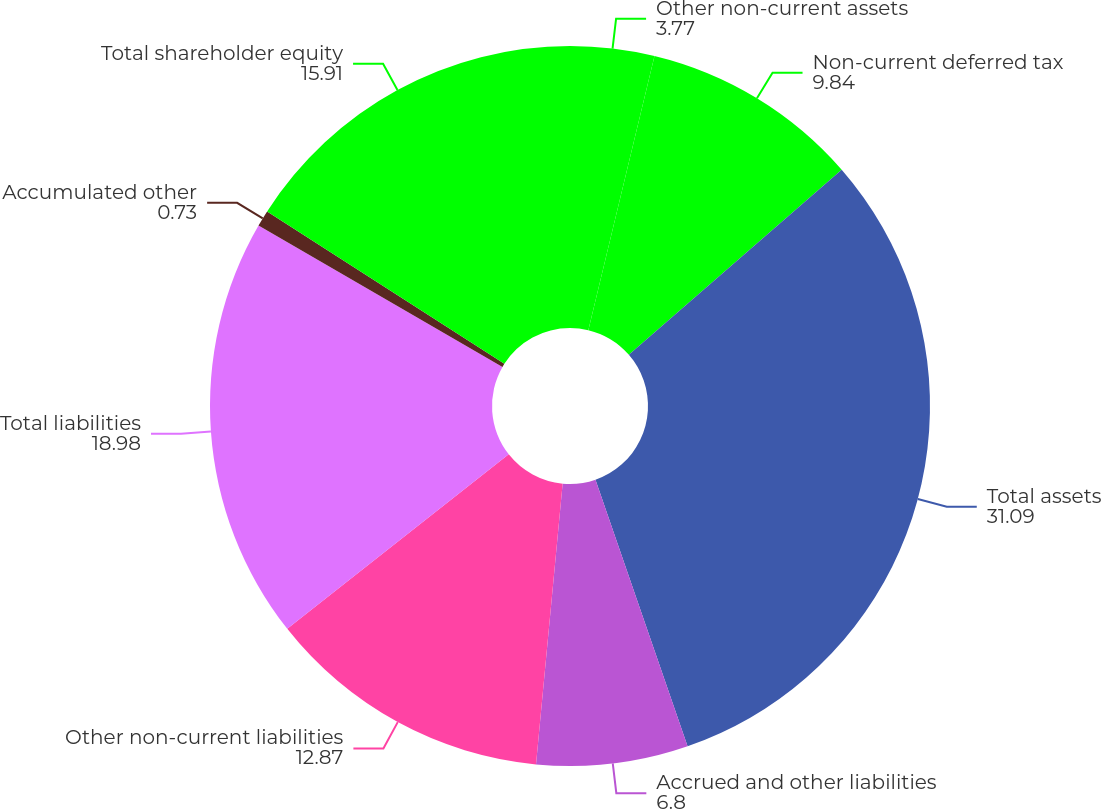<chart> <loc_0><loc_0><loc_500><loc_500><pie_chart><fcel>Other non-current assets<fcel>Non-current deferred tax<fcel>Total assets<fcel>Accrued and other liabilities<fcel>Other non-current liabilities<fcel>Total liabilities<fcel>Accumulated other<fcel>Total shareholder equity<nl><fcel>3.77%<fcel>9.84%<fcel>31.09%<fcel>6.8%<fcel>12.87%<fcel>18.98%<fcel>0.73%<fcel>15.91%<nl></chart> 